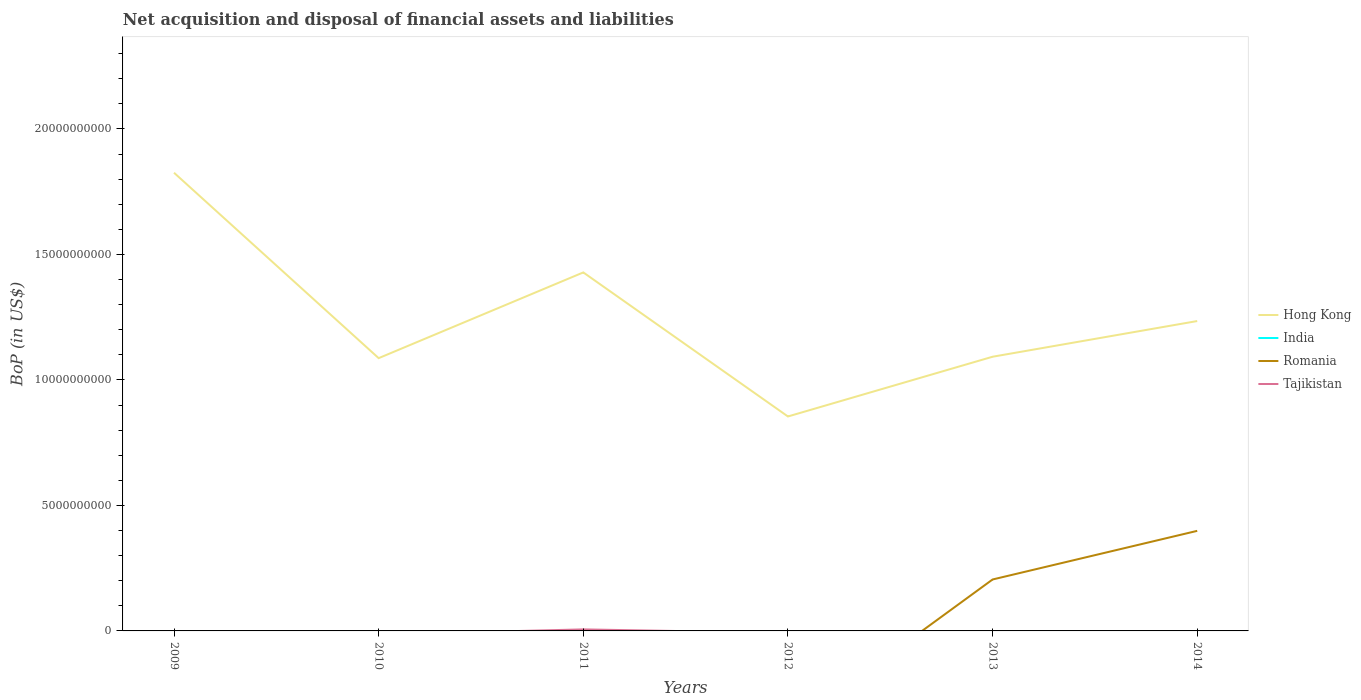Does the line corresponding to Hong Kong intersect with the line corresponding to India?
Give a very brief answer. No. Is the number of lines equal to the number of legend labels?
Keep it short and to the point. No. Across all years, what is the maximum Balance of Payments in Tajikistan?
Offer a terse response. 0. What is the total Balance of Payments in Hong Kong in the graph?
Make the answer very short. 3.97e+09. What is the difference between the highest and the second highest Balance of Payments in Tajikistan?
Keep it short and to the point. 6.09e+07. What is the difference between the highest and the lowest Balance of Payments in India?
Make the answer very short. 0. How many lines are there?
Your answer should be very brief. 3. How many years are there in the graph?
Offer a terse response. 6. Are the values on the major ticks of Y-axis written in scientific E-notation?
Provide a succinct answer. No. Does the graph contain any zero values?
Offer a very short reply. Yes. What is the title of the graph?
Your answer should be compact. Net acquisition and disposal of financial assets and liabilities. Does "Poland" appear as one of the legend labels in the graph?
Your answer should be very brief. No. What is the label or title of the X-axis?
Keep it short and to the point. Years. What is the label or title of the Y-axis?
Offer a terse response. BoP (in US$). What is the BoP (in US$) of Hong Kong in 2009?
Offer a terse response. 1.83e+1. What is the BoP (in US$) of India in 2009?
Provide a succinct answer. 0. What is the BoP (in US$) in Romania in 2009?
Make the answer very short. 0. What is the BoP (in US$) of Hong Kong in 2010?
Provide a short and direct response. 1.09e+1. What is the BoP (in US$) of Hong Kong in 2011?
Keep it short and to the point. 1.43e+1. What is the BoP (in US$) of India in 2011?
Your answer should be very brief. 0. What is the BoP (in US$) of Romania in 2011?
Ensure brevity in your answer.  0. What is the BoP (in US$) of Tajikistan in 2011?
Provide a short and direct response. 6.09e+07. What is the BoP (in US$) of Hong Kong in 2012?
Provide a short and direct response. 8.54e+09. What is the BoP (in US$) in Romania in 2012?
Ensure brevity in your answer.  0. What is the BoP (in US$) in Tajikistan in 2012?
Offer a terse response. 0. What is the BoP (in US$) in Hong Kong in 2013?
Give a very brief answer. 1.09e+1. What is the BoP (in US$) of Romania in 2013?
Give a very brief answer. 2.05e+09. What is the BoP (in US$) of Tajikistan in 2013?
Give a very brief answer. 0. What is the BoP (in US$) in Hong Kong in 2014?
Offer a very short reply. 1.23e+1. What is the BoP (in US$) of Romania in 2014?
Ensure brevity in your answer.  3.99e+09. What is the BoP (in US$) of Tajikistan in 2014?
Keep it short and to the point. 0. Across all years, what is the maximum BoP (in US$) of Hong Kong?
Your answer should be compact. 1.83e+1. Across all years, what is the maximum BoP (in US$) in Romania?
Provide a short and direct response. 3.99e+09. Across all years, what is the maximum BoP (in US$) of Tajikistan?
Give a very brief answer. 6.09e+07. Across all years, what is the minimum BoP (in US$) in Hong Kong?
Make the answer very short. 8.54e+09. Across all years, what is the minimum BoP (in US$) in Romania?
Ensure brevity in your answer.  0. What is the total BoP (in US$) in Hong Kong in the graph?
Offer a terse response. 7.52e+1. What is the total BoP (in US$) of Romania in the graph?
Give a very brief answer. 6.04e+09. What is the total BoP (in US$) of Tajikistan in the graph?
Your answer should be very brief. 6.09e+07. What is the difference between the BoP (in US$) in Hong Kong in 2009 and that in 2010?
Your response must be concise. 7.39e+09. What is the difference between the BoP (in US$) of Hong Kong in 2009 and that in 2011?
Offer a very short reply. 3.97e+09. What is the difference between the BoP (in US$) in Hong Kong in 2009 and that in 2012?
Provide a succinct answer. 9.71e+09. What is the difference between the BoP (in US$) in Hong Kong in 2009 and that in 2013?
Provide a short and direct response. 7.33e+09. What is the difference between the BoP (in US$) in Hong Kong in 2009 and that in 2014?
Your response must be concise. 5.91e+09. What is the difference between the BoP (in US$) in Hong Kong in 2010 and that in 2011?
Keep it short and to the point. -3.42e+09. What is the difference between the BoP (in US$) of Hong Kong in 2010 and that in 2012?
Your response must be concise. 2.32e+09. What is the difference between the BoP (in US$) of Hong Kong in 2010 and that in 2013?
Provide a short and direct response. -5.62e+07. What is the difference between the BoP (in US$) in Hong Kong in 2010 and that in 2014?
Make the answer very short. -1.48e+09. What is the difference between the BoP (in US$) in Hong Kong in 2011 and that in 2012?
Your response must be concise. 5.74e+09. What is the difference between the BoP (in US$) of Hong Kong in 2011 and that in 2013?
Provide a succinct answer. 3.36e+09. What is the difference between the BoP (in US$) of Hong Kong in 2011 and that in 2014?
Provide a succinct answer. 1.94e+09. What is the difference between the BoP (in US$) of Hong Kong in 2012 and that in 2013?
Your response must be concise. -2.38e+09. What is the difference between the BoP (in US$) of Hong Kong in 2012 and that in 2014?
Keep it short and to the point. -3.80e+09. What is the difference between the BoP (in US$) in Hong Kong in 2013 and that in 2014?
Your answer should be very brief. -1.42e+09. What is the difference between the BoP (in US$) of Romania in 2013 and that in 2014?
Offer a terse response. -1.94e+09. What is the difference between the BoP (in US$) of Hong Kong in 2009 and the BoP (in US$) of Tajikistan in 2011?
Your answer should be very brief. 1.82e+1. What is the difference between the BoP (in US$) in Hong Kong in 2009 and the BoP (in US$) in Romania in 2013?
Ensure brevity in your answer.  1.62e+1. What is the difference between the BoP (in US$) in Hong Kong in 2009 and the BoP (in US$) in Romania in 2014?
Keep it short and to the point. 1.43e+1. What is the difference between the BoP (in US$) in Hong Kong in 2010 and the BoP (in US$) in Tajikistan in 2011?
Your answer should be compact. 1.08e+1. What is the difference between the BoP (in US$) in Hong Kong in 2010 and the BoP (in US$) in Romania in 2013?
Keep it short and to the point. 8.82e+09. What is the difference between the BoP (in US$) of Hong Kong in 2010 and the BoP (in US$) of Romania in 2014?
Keep it short and to the point. 6.88e+09. What is the difference between the BoP (in US$) in Hong Kong in 2011 and the BoP (in US$) in Romania in 2013?
Provide a short and direct response. 1.22e+1. What is the difference between the BoP (in US$) of Hong Kong in 2011 and the BoP (in US$) of Romania in 2014?
Provide a succinct answer. 1.03e+1. What is the difference between the BoP (in US$) in Hong Kong in 2012 and the BoP (in US$) in Romania in 2013?
Provide a succinct answer. 6.49e+09. What is the difference between the BoP (in US$) of Hong Kong in 2012 and the BoP (in US$) of Romania in 2014?
Provide a short and direct response. 4.56e+09. What is the difference between the BoP (in US$) of Hong Kong in 2013 and the BoP (in US$) of Romania in 2014?
Provide a succinct answer. 6.94e+09. What is the average BoP (in US$) of Hong Kong per year?
Give a very brief answer. 1.25e+1. What is the average BoP (in US$) in Romania per year?
Your answer should be compact. 1.01e+09. What is the average BoP (in US$) of Tajikistan per year?
Provide a succinct answer. 1.01e+07. In the year 2011, what is the difference between the BoP (in US$) of Hong Kong and BoP (in US$) of Tajikistan?
Provide a short and direct response. 1.42e+1. In the year 2013, what is the difference between the BoP (in US$) of Hong Kong and BoP (in US$) of Romania?
Ensure brevity in your answer.  8.87e+09. In the year 2014, what is the difference between the BoP (in US$) in Hong Kong and BoP (in US$) in Romania?
Offer a very short reply. 8.36e+09. What is the ratio of the BoP (in US$) of Hong Kong in 2009 to that in 2010?
Provide a short and direct response. 1.68. What is the ratio of the BoP (in US$) of Hong Kong in 2009 to that in 2011?
Provide a succinct answer. 1.28. What is the ratio of the BoP (in US$) in Hong Kong in 2009 to that in 2012?
Provide a short and direct response. 2.14. What is the ratio of the BoP (in US$) in Hong Kong in 2009 to that in 2013?
Your answer should be very brief. 1.67. What is the ratio of the BoP (in US$) in Hong Kong in 2009 to that in 2014?
Offer a terse response. 1.48. What is the ratio of the BoP (in US$) of Hong Kong in 2010 to that in 2011?
Provide a short and direct response. 0.76. What is the ratio of the BoP (in US$) in Hong Kong in 2010 to that in 2012?
Offer a terse response. 1.27. What is the ratio of the BoP (in US$) of Hong Kong in 2010 to that in 2014?
Offer a very short reply. 0.88. What is the ratio of the BoP (in US$) in Hong Kong in 2011 to that in 2012?
Your answer should be compact. 1.67. What is the ratio of the BoP (in US$) in Hong Kong in 2011 to that in 2013?
Your answer should be very brief. 1.31. What is the ratio of the BoP (in US$) in Hong Kong in 2011 to that in 2014?
Your answer should be compact. 1.16. What is the ratio of the BoP (in US$) of Hong Kong in 2012 to that in 2013?
Give a very brief answer. 0.78. What is the ratio of the BoP (in US$) of Hong Kong in 2012 to that in 2014?
Give a very brief answer. 0.69. What is the ratio of the BoP (in US$) in Hong Kong in 2013 to that in 2014?
Offer a very short reply. 0.88. What is the ratio of the BoP (in US$) of Romania in 2013 to that in 2014?
Offer a very short reply. 0.51. What is the difference between the highest and the second highest BoP (in US$) in Hong Kong?
Make the answer very short. 3.97e+09. What is the difference between the highest and the lowest BoP (in US$) of Hong Kong?
Give a very brief answer. 9.71e+09. What is the difference between the highest and the lowest BoP (in US$) of Romania?
Your answer should be compact. 3.99e+09. What is the difference between the highest and the lowest BoP (in US$) in Tajikistan?
Offer a terse response. 6.09e+07. 